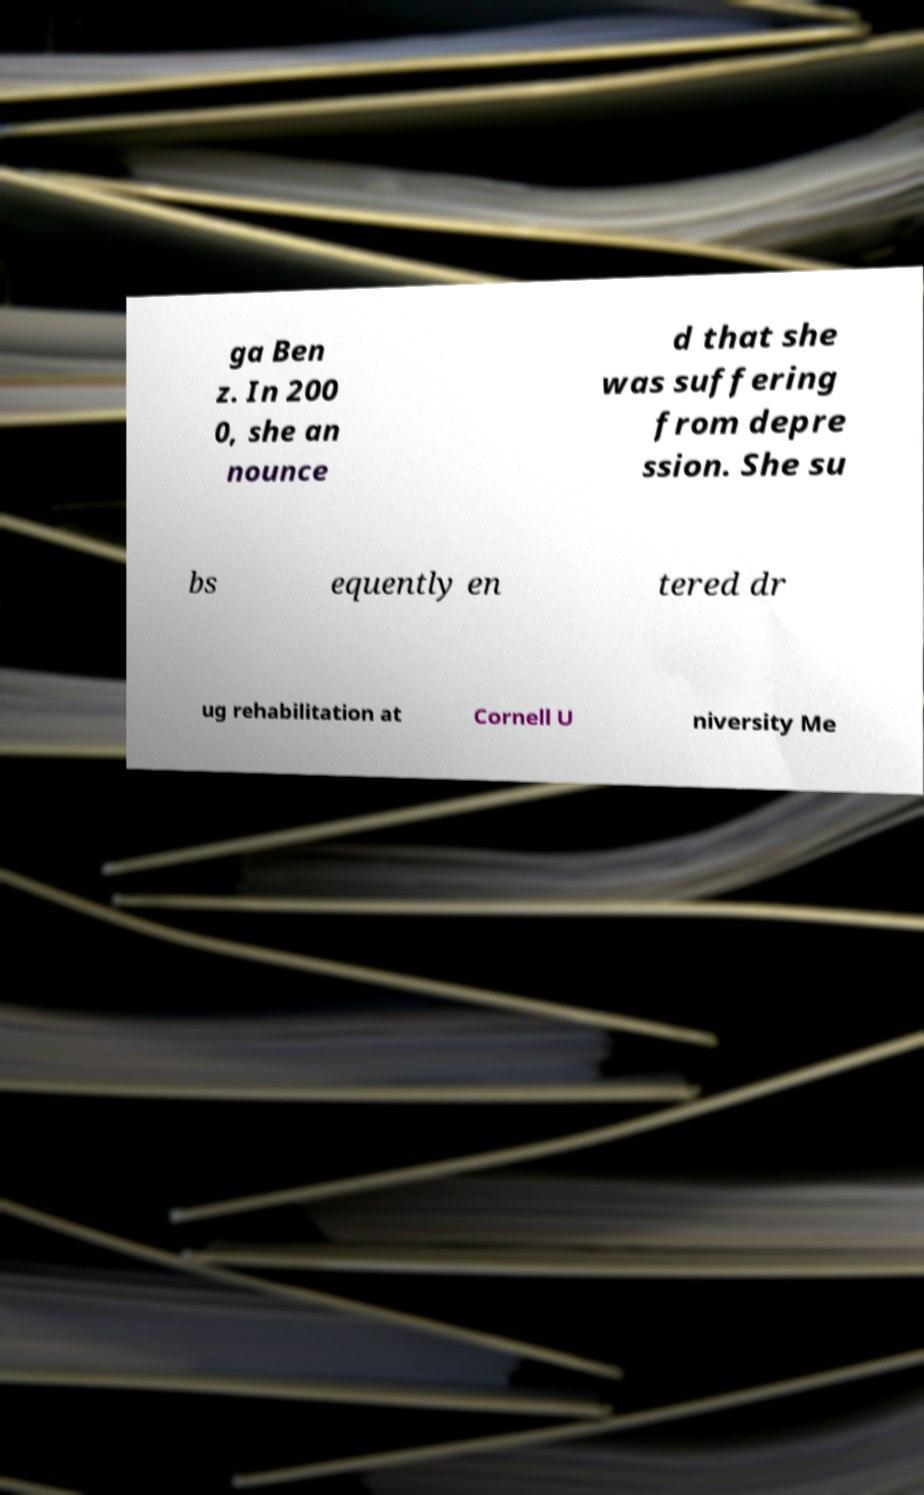What messages or text are displayed in this image? I need them in a readable, typed format. ga Ben z. In 200 0, she an nounce d that she was suffering from depre ssion. She su bs equently en tered dr ug rehabilitation at Cornell U niversity Me 